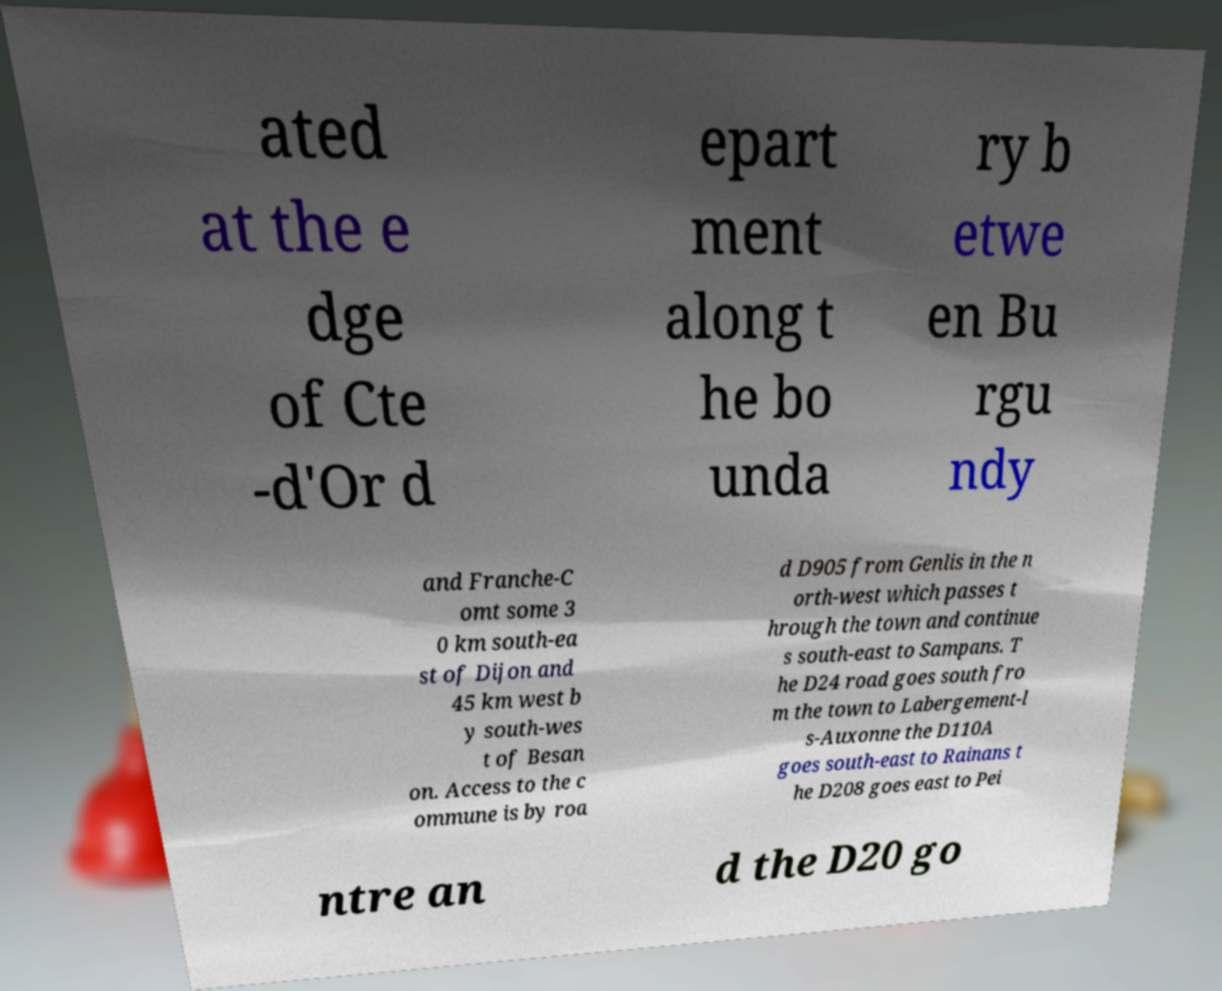For documentation purposes, I need the text within this image transcribed. Could you provide that? ated at the e dge of Cte -d'Or d epart ment along t he bo unda ry b etwe en Bu rgu ndy and Franche-C omt some 3 0 km south-ea st of Dijon and 45 km west b y south-wes t of Besan on. Access to the c ommune is by roa d D905 from Genlis in the n orth-west which passes t hrough the town and continue s south-east to Sampans. T he D24 road goes south fro m the town to Labergement-l s-Auxonne the D110A goes south-east to Rainans t he D208 goes east to Pei ntre an d the D20 go 